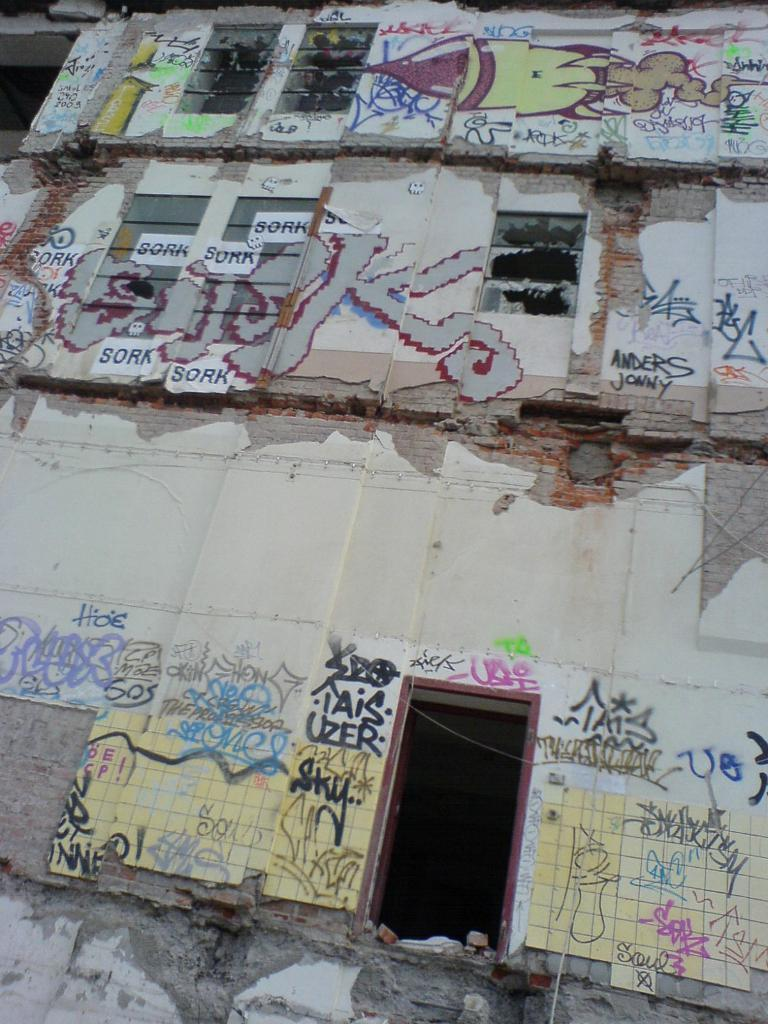What is the main subject in the foreground of the image? There is an entrance of a building in the foreground of the image. What can be seen on the building in the image? Graffiti paintings are present on the building. What type of board can be seen floating on the moon in the image? There is no board or moon present in the image; it features an entrance of a building with graffiti paintings. 